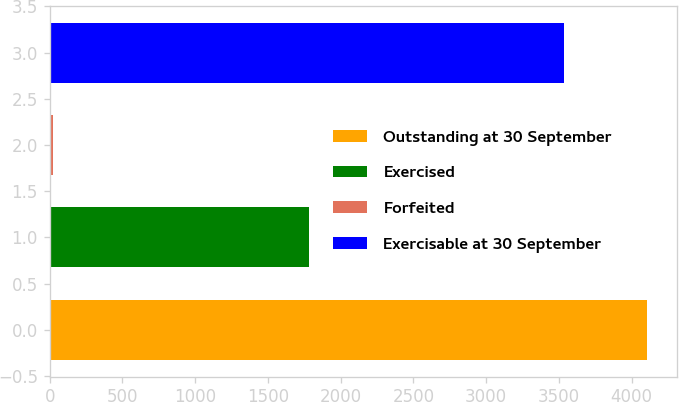<chart> <loc_0><loc_0><loc_500><loc_500><bar_chart><fcel>Outstanding at 30 September<fcel>Exercised<fcel>Forfeited<fcel>Exercisable at 30 September<nl><fcel>4106.9<fcel>1783<fcel>26<fcel>3537<nl></chart> 